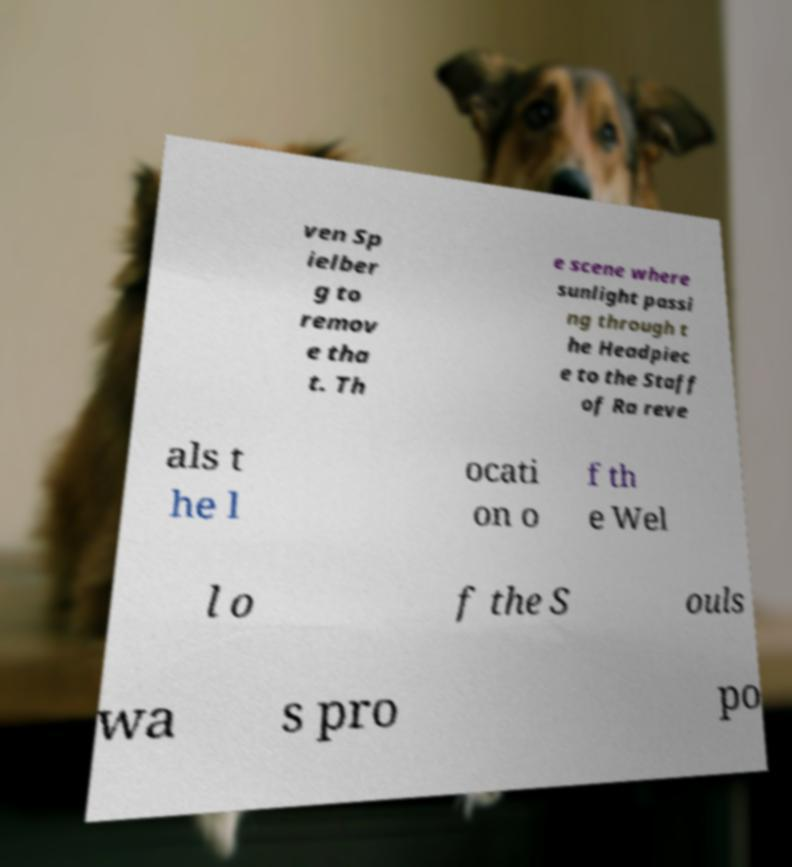Please identify and transcribe the text found in this image. ven Sp ielber g to remov e tha t. Th e scene where sunlight passi ng through t he Headpiec e to the Staff of Ra reve als t he l ocati on o f th e Wel l o f the S ouls wa s pro po 